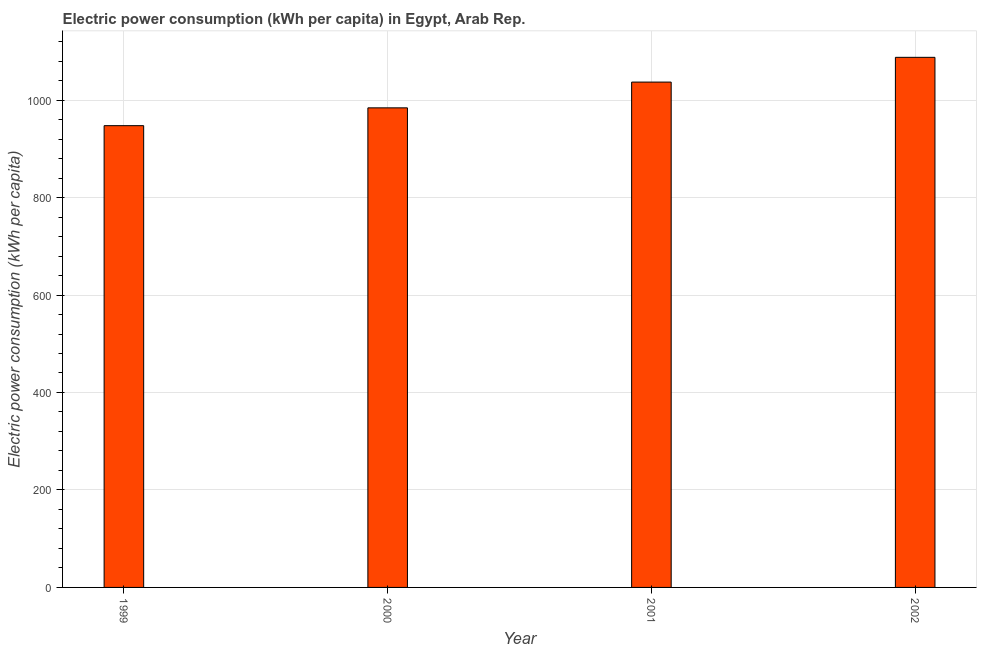Does the graph contain any zero values?
Give a very brief answer. No. Does the graph contain grids?
Ensure brevity in your answer.  Yes. What is the title of the graph?
Offer a very short reply. Electric power consumption (kWh per capita) in Egypt, Arab Rep. What is the label or title of the Y-axis?
Ensure brevity in your answer.  Electric power consumption (kWh per capita). What is the electric power consumption in 2002?
Give a very brief answer. 1087.72. Across all years, what is the maximum electric power consumption?
Give a very brief answer. 1087.72. Across all years, what is the minimum electric power consumption?
Make the answer very short. 947.51. In which year was the electric power consumption maximum?
Keep it short and to the point. 2002. What is the sum of the electric power consumption?
Provide a succinct answer. 4056.24. What is the difference between the electric power consumption in 1999 and 2000?
Offer a terse response. -36.56. What is the average electric power consumption per year?
Ensure brevity in your answer.  1014.06. What is the median electric power consumption?
Your response must be concise. 1010.5. In how many years, is the electric power consumption greater than 560 kWh per capita?
Ensure brevity in your answer.  4. Do a majority of the years between 2002 and 2001 (inclusive) have electric power consumption greater than 520 kWh per capita?
Your response must be concise. No. What is the ratio of the electric power consumption in 2001 to that in 2002?
Provide a succinct answer. 0.95. What is the difference between the highest and the second highest electric power consumption?
Your response must be concise. 50.78. Is the sum of the electric power consumption in 1999 and 2002 greater than the maximum electric power consumption across all years?
Make the answer very short. Yes. What is the difference between the highest and the lowest electric power consumption?
Provide a succinct answer. 140.21. How many bars are there?
Provide a short and direct response. 4. What is the difference between two consecutive major ticks on the Y-axis?
Give a very brief answer. 200. Are the values on the major ticks of Y-axis written in scientific E-notation?
Your answer should be compact. No. What is the Electric power consumption (kWh per capita) of 1999?
Offer a very short reply. 947.51. What is the Electric power consumption (kWh per capita) in 2000?
Your response must be concise. 984.07. What is the Electric power consumption (kWh per capita) in 2001?
Ensure brevity in your answer.  1036.94. What is the Electric power consumption (kWh per capita) of 2002?
Ensure brevity in your answer.  1087.72. What is the difference between the Electric power consumption (kWh per capita) in 1999 and 2000?
Your response must be concise. -36.56. What is the difference between the Electric power consumption (kWh per capita) in 1999 and 2001?
Give a very brief answer. -89.43. What is the difference between the Electric power consumption (kWh per capita) in 1999 and 2002?
Ensure brevity in your answer.  -140.21. What is the difference between the Electric power consumption (kWh per capita) in 2000 and 2001?
Ensure brevity in your answer.  -52.88. What is the difference between the Electric power consumption (kWh per capita) in 2000 and 2002?
Provide a succinct answer. -103.66. What is the difference between the Electric power consumption (kWh per capita) in 2001 and 2002?
Your response must be concise. -50.78. What is the ratio of the Electric power consumption (kWh per capita) in 1999 to that in 2001?
Provide a succinct answer. 0.91. What is the ratio of the Electric power consumption (kWh per capita) in 1999 to that in 2002?
Keep it short and to the point. 0.87. What is the ratio of the Electric power consumption (kWh per capita) in 2000 to that in 2001?
Offer a terse response. 0.95. What is the ratio of the Electric power consumption (kWh per capita) in 2000 to that in 2002?
Provide a short and direct response. 0.91. What is the ratio of the Electric power consumption (kWh per capita) in 2001 to that in 2002?
Your response must be concise. 0.95. 